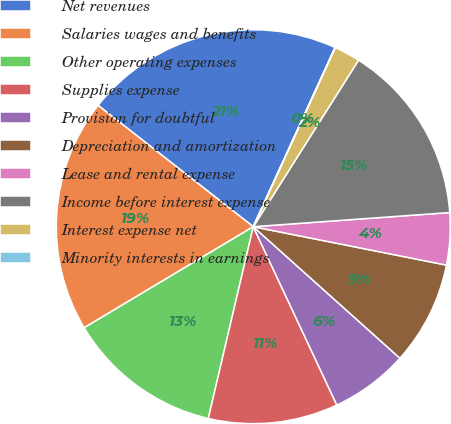Convert chart. <chart><loc_0><loc_0><loc_500><loc_500><pie_chart><fcel>Net revenues<fcel>Salaries wages and benefits<fcel>Other operating expenses<fcel>Supplies expense<fcel>Provision for doubtful<fcel>Depreciation and amortization<fcel>Lease and rental expense<fcel>Income before interest expense<fcel>Interest expense net<fcel>Minority interests in earnings<nl><fcel>21.25%<fcel>19.13%<fcel>12.76%<fcel>10.64%<fcel>6.39%<fcel>8.51%<fcel>4.27%<fcel>14.88%<fcel>2.14%<fcel>0.02%<nl></chart> 